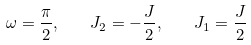<formula> <loc_0><loc_0><loc_500><loc_500>\omega = \frac { \pi } { 2 } , \quad J _ { 2 } = - \frac { J } { 2 } , \quad J _ { 1 } = \frac { J } { 2 }</formula> 